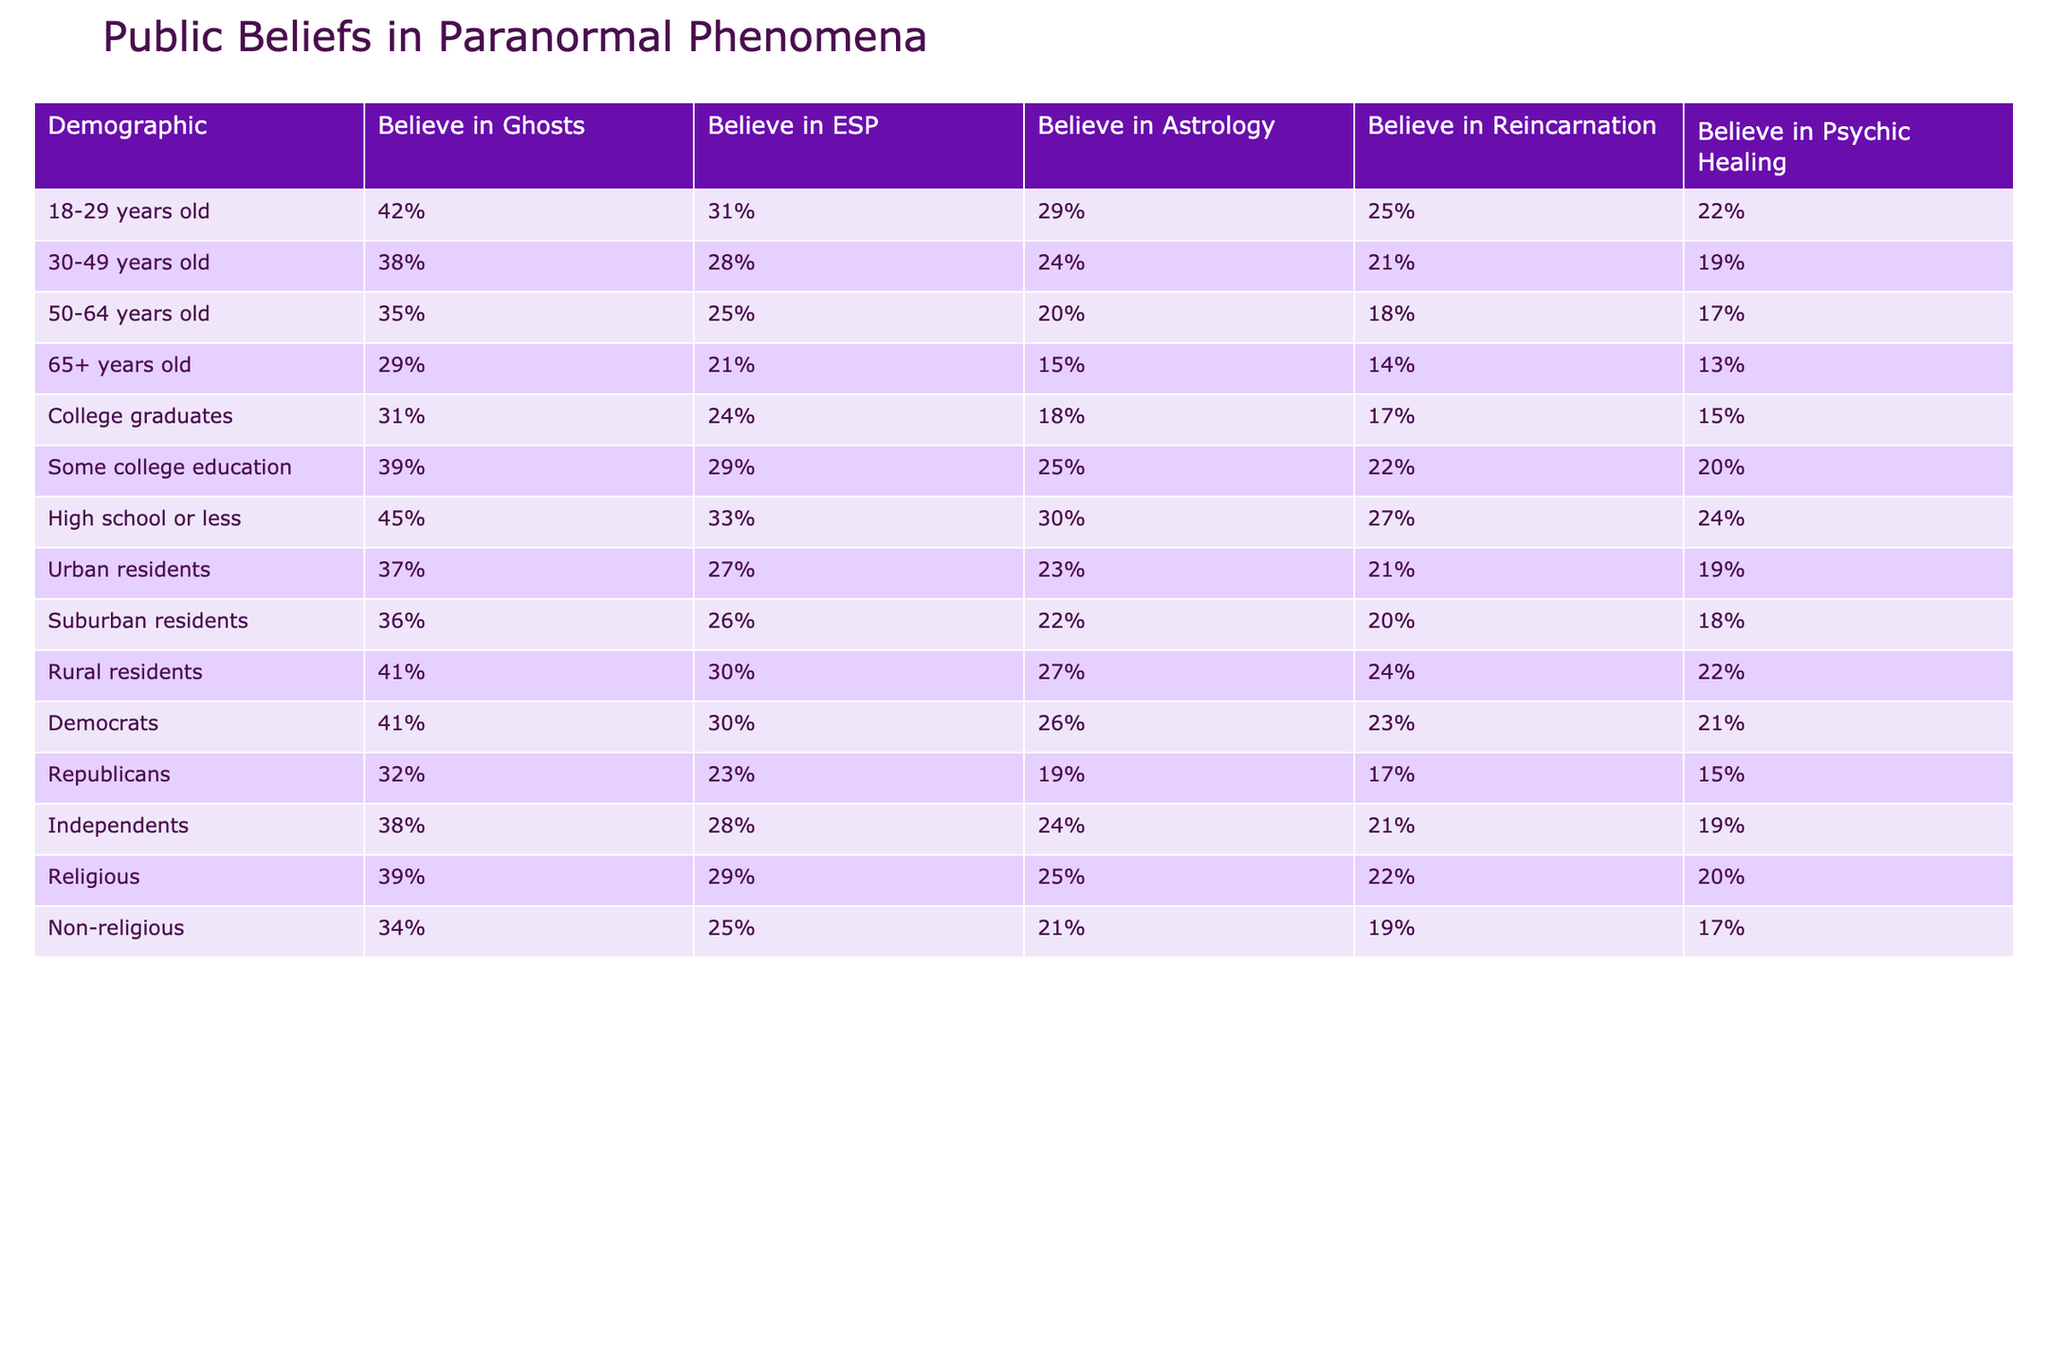What percentage of 18-29 year olds believe in ghosts? According to the table, 42% of individuals aged 18-29 believe in ghosts. This percentage is directly stated in the "Believe in Ghosts" column for that specific demographic.
Answer: 42% What is the belief percentage of college graduates in astrology? The table indicates that 18% of college graduates believe in astrology, which is listed directly under the "Believe in Astrology" column for that demographic.
Answer: 18% Which demographic group has the highest belief in psychic healing? Looking at the table, the demographic group with the highest belief in psychic healing is "High school or less," with 24%. This is found by comparing the percentages for all demographics listed under "Believe in Psychic Healing."
Answer: High school or less What is the difference in belief percentages in reincarnation between 30-49 year olds and 65+ year olds? For 30-49 year olds, the belief percentage in reincarnation is 21%, while for 65+ year olds, it is 14%. Therefore, the difference is 21% - 14% = 7%. This calculation is derived from the values shown in the "Believe in Reincarnation" column for both age demographics.
Answer: 7% Do a majority of suburban residents believe in ESP? According to the table, 26% of suburban residents believe in ESP. Since this percentage is less than 50%, it indicates that a majority do not believe. Thus, the answer to the question is based on comparing the percentage (26%) to 50%.
Answer: No What is the average percentage of belief in astrology among urban, suburban, and rural residents? From the table, urban residents show 23%, suburban residents have 22%, and rural residents show 27% belief in astrology. To find the average, we sum these values: 23 + 22 + 27 = 72 and divide by 3, yielding an average of 72/3 = 24%. This step involves basic arithmetic operations applied to the relevant demographic groups.
Answer: 24% Which demographic has the lowest percentage of belief in ghosts and what is the percentage? The table shows that the demographic with the lowest belief in ghosts is "65+ years old," with a percentage of 29%. This is determined by checking the "Believe in Ghosts" column for all listed demographics and identifying the lowest value.
Answer: 29% Is there a higher belief in psychic healing among Democrats compared to Republicans? The table shows that Democrats have 21% belief in psychic healing, while Republicans have 15%. Since 21% is greater than 15%, this indicates that Democrats do have a higher belief compared to Republicans. This conclusion is drawn by comparing the values directly in the "Believe in Psychic Healing" column.
Answer: Yes What percentage of non-religious individuals believe in reincarnation? From the table, it is noted that 19% of non-religious individuals believe in reincarnation. The answer is found directly from the "Believe in Reincarnation" column corresponding to the non-religious demographic.
Answer: 19% What is the trend in belief in ESP as age increases from 18-29 to 65+? The table shows that belief in ESP decreases with age: 31% for 18-29, 28% for 30-49, 25% for 50-64, and 21% for 65+. This indicates a downward trend as the demographic ages, supported by checking the values sequentially in the "Believe in ESP" column.
Answer: Decreasing trend What is the total percentage of belief in ghost, ESP, astrology, reincarnation, and psychic healing among high school or less individuals? The total belief percentages are: Ghosts (45%) + ESP (33%) + Astrology (30%) + Reincarnation (27%) + Psychic Healing (24%) = 45 + 33 + 30 + 27 + 24 = 159%. The calculation involves summing all the belief percentages listed under the "High school or less" demographic across all belief categories.
Answer: 159% 